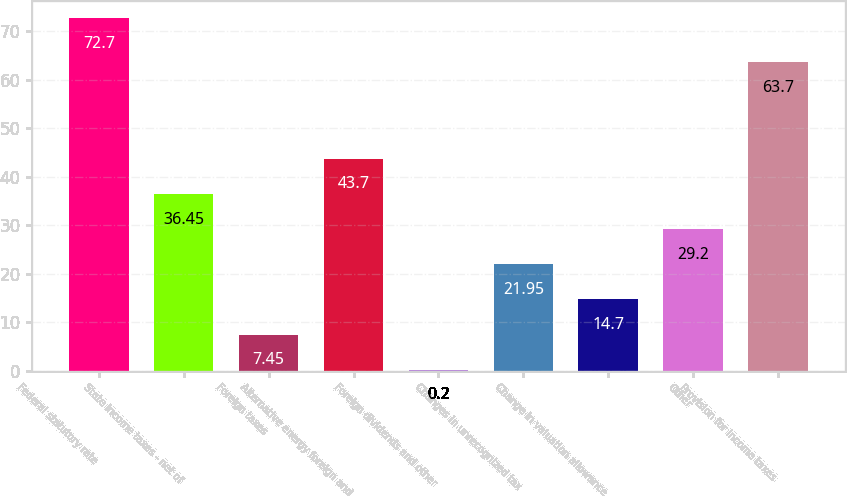Convert chart to OTSL. <chart><loc_0><loc_0><loc_500><loc_500><bar_chart><fcel>Federal statutory rate<fcel>State income taxes - net of<fcel>Foreign taxes<fcel>Alternative energy foreign and<fcel>Foreign dividends and other<fcel>Changes in unrecognized tax<fcel>Change in valuation allowance<fcel>Other<fcel>Provision for income taxes<nl><fcel>72.7<fcel>36.45<fcel>7.45<fcel>43.7<fcel>0.2<fcel>21.95<fcel>14.7<fcel>29.2<fcel>63.7<nl></chart> 